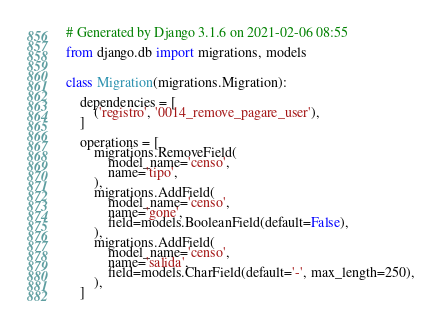<code> <loc_0><loc_0><loc_500><loc_500><_Python_># Generated by Django 3.1.6 on 2021-02-06 08:55

from django.db import migrations, models


class Migration(migrations.Migration):

    dependencies = [
        ('registro', '0014_remove_pagare_user'),
    ]

    operations = [
        migrations.RemoveField(
            model_name='censo',
            name='tipo',
        ),
        migrations.AddField(
            model_name='censo',
            name='gone',
            field=models.BooleanField(default=False),
        ),
        migrations.AddField(
            model_name='censo',
            name='salida',
            field=models.CharField(default='-', max_length=250),
        ),
    ]
</code> 